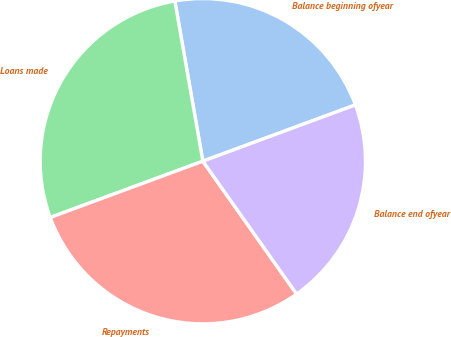<chart> <loc_0><loc_0><loc_500><loc_500><pie_chart><fcel>Balance beginning ofyear<fcel>Loans made<fcel>Repayments<fcel>Balance end ofyear<nl><fcel>22.13%<fcel>27.87%<fcel>29.16%<fcel>20.84%<nl></chart> 